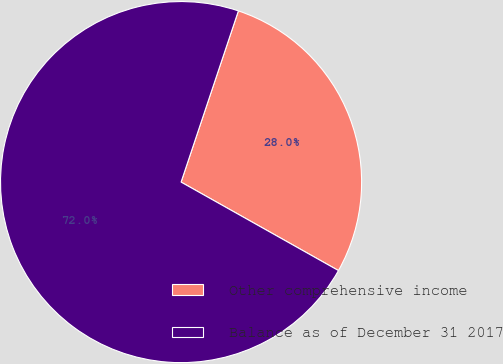Convert chart. <chart><loc_0><loc_0><loc_500><loc_500><pie_chart><fcel>Other comprehensive income<fcel>Balance as of December 31 2017<nl><fcel>28.01%<fcel>71.99%<nl></chart> 